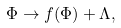<formula> <loc_0><loc_0><loc_500><loc_500>\Phi \rightarrow f ( \Phi ) + \Lambda ,</formula> 